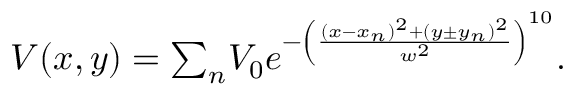<formula> <loc_0><loc_0><loc_500><loc_500>\begin{array} { r } { V ( x , y ) = { \sum _ { n } } V _ { 0 } e ^ { - \left ( \frac { ( x - x _ { n } ) ^ { 2 } + ( y \pm y _ { n } ) ^ { 2 } } { w ^ { 2 } } \right ) ^ { 1 0 } } . } \end{array}</formula> 